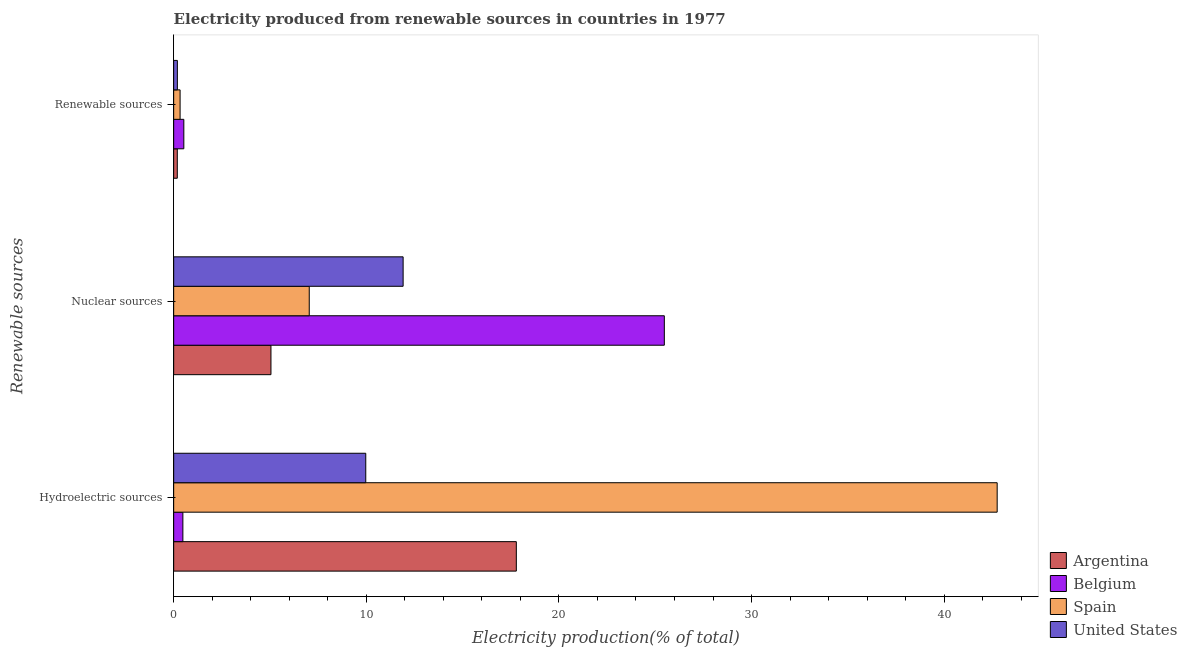Are the number of bars per tick equal to the number of legend labels?
Keep it short and to the point. Yes. Are the number of bars on each tick of the Y-axis equal?
Provide a succinct answer. Yes. How many bars are there on the 2nd tick from the top?
Make the answer very short. 4. How many bars are there on the 3rd tick from the bottom?
Your answer should be very brief. 4. What is the label of the 3rd group of bars from the top?
Offer a very short reply. Hydroelectric sources. What is the percentage of electricity produced by renewable sources in United States?
Provide a succinct answer. 0.19. Across all countries, what is the maximum percentage of electricity produced by renewable sources?
Your answer should be compact. 0.53. Across all countries, what is the minimum percentage of electricity produced by hydroelectric sources?
Keep it short and to the point. 0.48. In which country was the percentage of electricity produced by nuclear sources maximum?
Provide a succinct answer. Belgium. What is the total percentage of electricity produced by hydroelectric sources in the graph?
Provide a succinct answer. 70.99. What is the difference between the percentage of electricity produced by renewable sources in Argentina and that in Belgium?
Keep it short and to the point. -0.34. What is the difference between the percentage of electricity produced by hydroelectric sources in United States and the percentage of electricity produced by nuclear sources in Argentina?
Offer a terse response. 4.92. What is the average percentage of electricity produced by hydroelectric sources per country?
Make the answer very short. 17.75. What is the difference between the percentage of electricity produced by renewable sources and percentage of electricity produced by hydroelectric sources in Spain?
Keep it short and to the point. -42.42. What is the ratio of the percentage of electricity produced by hydroelectric sources in Spain to that in Argentina?
Make the answer very short. 2.4. Is the difference between the percentage of electricity produced by hydroelectric sources in United States and Argentina greater than the difference between the percentage of electricity produced by renewable sources in United States and Argentina?
Offer a terse response. No. What is the difference between the highest and the second highest percentage of electricity produced by hydroelectric sources?
Provide a short and direct response. 24.96. What is the difference between the highest and the lowest percentage of electricity produced by nuclear sources?
Provide a succinct answer. 20.42. In how many countries, is the percentage of electricity produced by nuclear sources greater than the average percentage of electricity produced by nuclear sources taken over all countries?
Your answer should be compact. 1. What does the 1st bar from the top in Nuclear sources represents?
Provide a succinct answer. United States. Are all the bars in the graph horizontal?
Ensure brevity in your answer.  Yes. How many countries are there in the graph?
Provide a succinct answer. 4. What is the difference between two consecutive major ticks on the X-axis?
Provide a succinct answer. 10. Does the graph contain any zero values?
Give a very brief answer. No. Does the graph contain grids?
Your answer should be compact. No. How many legend labels are there?
Provide a succinct answer. 4. What is the title of the graph?
Your answer should be compact. Electricity produced from renewable sources in countries in 1977. What is the label or title of the Y-axis?
Provide a short and direct response. Renewable sources. What is the Electricity production(% of total) of Argentina in Hydroelectric sources?
Your answer should be very brief. 17.79. What is the Electricity production(% of total) of Belgium in Hydroelectric sources?
Offer a terse response. 0.48. What is the Electricity production(% of total) in Spain in Hydroelectric sources?
Your answer should be very brief. 42.75. What is the Electricity production(% of total) in United States in Hydroelectric sources?
Keep it short and to the point. 9.97. What is the Electricity production(% of total) of Argentina in Nuclear sources?
Provide a short and direct response. 5.05. What is the Electricity production(% of total) of Belgium in Nuclear sources?
Offer a terse response. 25.47. What is the Electricity production(% of total) in Spain in Nuclear sources?
Ensure brevity in your answer.  7.04. What is the Electricity production(% of total) of United States in Nuclear sources?
Your answer should be compact. 11.91. What is the Electricity production(% of total) in Argentina in Renewable sources?
Keep it short and to the point. 0.19. What is the Electricity production(% of total) of Belgium in Renewable sources?
Offer a terse response. 0.53. What is the Electricity production(% of total) of Spain in Renewable sources?
Offer a terse response. 0.33. What is the Electricity production(% of total) in United States in Renewable sources?
Ensure brevity in your answer.  0.19. Across all Renewable sources, what is the maximum Electricity production(% of total) in Argentina?
Keep it short and to the point. 17.79. Across all Renewable sources, what is the maximum Electricity production(% of total) of Belgium?
Your answer should be very brief. 25.47. Across all Renewable sources, what is the maximum Electricity production(% of total) of Spain?
Your response must be concise. 42.75. Across all Renewable sources, what is the maximum Electricity production(% of total) in United States?
Give a very brief answer. 11.91. Across all Renewable sources, what is the minimum Electricity production(% of total) in Argentina?
Your answer should be compact. 0.19. Across all Renewable sources, what is the minimum Electricity production(% of total) of Belgium?
Provide a short and direct response. 0.48. Across all Renewable sources, what is the minimum Electricity production(% of total) in Spain?
Offer a very short reply. 0.33. Across all Renewable sources, what is the minimum Electricity production(% of total) of United States?
Ensure brevity in your answer.  0.19. What is the total Electricity production(% of total) in Argentina in the graph?
Your answer should be compact. 23.03. What is the total Electricity production(% of total) of Belgium in the graph?
Give a very brief answer. 26.48. What is the total Electricity production(% of total) in Spain in the graph?
Offer a terse response. 50.13. What is the total Electricity production(% of total) of United States in the graph?
Your response must be concise. 22.08. What is the difference between the Electricity production(% of total) of Argentina in Hydroelectric sources and that in Nuclear sources?
Provide a succinct answer. 12.74. What is the difference between the Electricity production(% of total) in Belgium in Hydroelectric sources and that in Nuclear sources?
Your answer should be compact. -25. What is the difference between the Electricity production(% of total) in Spain in Hydroelectric sources and that in Nuclear sources?
Make the answer very short. 35.72. What is the difference between the Electricity production(% of total) of United States in Hydroelectric sources and that in Nuclear sources?
Ensure brevity in your answer.  -1.94. What is the difference between the Electricity production(% of total) in Argentina in Hydroelectric sources and that in Renewable sources?
Your answer should be very brief. 17.6. What is the difference between the Electricity production(% of total) in Belgium in Hydroelectric sources and that in Renewable sources?
Provide a short and direct response. -0.05. What is the difference between the Electricity production(% of total) of Spain in Hydroelectric sources and that in Renewable sources?
Your answer should be compact. 42.42. What is the difference between the Electricity production(% of total) of United States in Hydroelectric sources and that in Renewable sources?
Your answer should be compact. 9.78. What is the difference between the Electricity production(% of total) of Argentina in Nuclear sources and that in Renewable sources?
Ensure brevity in your answer.  4.86. What is the difference between the Electricity production(% of total) of Belgium in Nuclear sources and that in Renewable sources?
Provide a short and direct response. 24.95. What is the difference between the Electricity production(% of total) of Spain in Nuclear sources and that in Renewable sources?
Give a very brief answer. 6.71. What is the difference between the Electricity production(% of total) in United States in Nuclear sources and that in Renewable sources?
Your response must be concise. 11.72. What is the difference between the Electricity production(% of total) in Argentina in Hydroelectric sources and the Electricity production(% of total) in Belgium in Nuclear sources?
Your response must be concise. -7.68. What is the difference between the Electricity production(% of total) in Argentina in Hydroelectric sources and the Electricity production(% of total) in Spain in Nuclear sources?
Give a very brief answer. 10.75. What is the difference between the Electricity production(% of total) of Argentina in Hydroelectric sources and the Electricity production(% of total) of United States in Nuclear sources?
Keep it short and to the point. 5.88. What is the difference between the Electricity production(% of total) in Belgium in Hydroelectric sources and the Electricity production(% of total) in Spain in Nuclear sources?
Give a very brief answer. -6.56. What is the difference between the Electricity production(% of total) in Belgium in Hydroelectric sources and the Electricity production(% of total) in United States in Nuclear sources?
Ensure brevity in your answer.  -11.43. What is the difference between the Electricity production(% of total) in Spain in Hydroelectric sources and the Electricity production(% of total) in United States in Nuclear sources?
Your answer should be very brief. 30.84. What is the difference between the Electricity production(% of total) in Argentina in Hydroelectric sources and the Electricity production(% of total) in Belgium in Renewable sources?
Your answer should be very brief. 17.26. What is the difference between the Electricity production(% of total) of Argentina in Hydroelectric sources and the Electricity production(% of total) of Spain in Renewable sources?
Your answer should be compact. 17.46. What is the difference between the Electricity production(% of total) of Argentina in Hydroelectric sources and the Electricity production(% of total) of United States in Renewable sources?
Offer a very short reply. 17.6. What is the difference between the Electricity production(% of total) of Belgium in Hydroelectric sources and the Electricity production(% of total) of Spain in Renewable sources?
Provide a succinct answer. 0.14. What is the difference between the Electricity production(% of total) in Belgium in Hydroelectric sources and the Electricity production(% of total) in United States in Renewable sources?
Give a very brief answer. 0.29. What is the difference between the Electricity production(% of total) in Spain in Hydroelectric sources and the Electricity production(% of total) in United States in Renewable sources?
Offer a terse response. 42.56. What is the difference between the Electricity production(% of total) in Argentina in Nuclear sources and the Electricity production(% of total) in Belgium in Renewable sources?
Give a very brief answer. 4.52. What is the difference between the Electricity production(% of total) of Argentina in Nuclear sources and the Electricity production(% of total) of Spain in Renewable sources?
Provide a succinct answer. 4.72. What is the difference between the Electricity production(% of total) in Argentina in Nuclear sources and the Electricity production(% of total) in United States in Renewable sources?
Offer a very short reply. 4.86. What is the difference between the Electricity production(% of total) of Belgium in Nuclear sources and the Electricity production(% of total) of Spain in Renewable sources?
Give a very brief answer. 25.14. What is the difference between the Electricity production(% of total) of Belgium in Nuclear sources and the Electricity production(% of total) of United States in Renewable sources?
Give a very brief answer. 25.28. What is the difference between the Electricity production(% of total) of Spain in Nuclear sources and the Electricity production(% of total) of United States in Renewable sources?
Provide a succinct answer. 6.85. What is the average Electricity production(% of total) in Argentina per Renewable sources?
Make the answer very short. 7.68. What is the average Electricity production(% of total) of Belgium per Renewable sources?
Provide a succinct answer. 8.83. What is the average Electricity production(% of total) in Spain per Renewable sources?
Keep it short and to the point. 16.71. What is the average Electricity production(% of total) of United States per Renewable sources?
Keep it short and to the point. 7.36. What is the difference between the Electricity production(% of total) in Argentina and Electricity production(% of total) in Belgium in Hydroelectric sources?
Your answer should be compact. 17.31. What is the difference between the Electricity production(% of total) of Argentina and Electricity production(% of total) of Spain in Hydroelectric sources?
Make the answer very short. -24.96. What is the difference between the Electricity production(% of total) of Argentina and Electricity production(% of total) of United States in Hydroelectric sources?
Make the answer very short. 7.82. What is the difference between the Electricity production(% of total) of Belgium and Electricity production(% of total) of Spain in Hydroelectric sources?
Keep it short and to the point. -42.28. What is the difference between the Electricity production(% of total) of Belgium and Electricity production(% of total) of United States in Hydroelectric sources?
Offer a very short reply. -9.49. What is the difference between the Electricity production(% of total) of Spain and Electricity production(% of total) of United States in Hydroelectric sources?
Make the answer very short. 32.78. What is the difference between the Electricity production(% of total) in Argentina and Electricity production(% of total) in Belgium in Nuclear sources?
Your response must be concise. -20.42. What is the difference between the Electricity production(% of total) of Argentina and Electricity production(% of total) of Spain in Nuclear sources?
Keep it short and to the point. -1.99. What is the difference between the Electricity production(% of total) in Argentina and Electricity production(% of total) in United States in Nuclear sources?
Make the answer very short. -6.86. What is the difference between the Electricity production(% of total) in Belgium and Electricity production(% of total) in Spain in Nuclear sources?
Make the answer very short. 18.43. What is the difference between the Electricity production(% of total) in Belgium and Electricity production(% of total) in United States in Nuclear sources?
Provide a short and direct response. 13.56. What is the difference between the Electricity production(% of total) in Spain and Electricity production(% of total) in United States in Nuclear sources?
Make the answer very short. -4.87. What is the difference between the Electricity production(% of total) in Argentina and Electricity production(% of total) in Belgium in Renewable sources?
Offer a very short reply. -0.34. What is the difference between the Electricity production(% of total) of Argentina and Electricity production(% of total) of Spain in Renewable sources?
Your response must be concise. -0.15. What is the difference between the Electricity production(% of total) in Argentina and Electricity production(% of total) in United States in Renewable sources?
Offer a very short reply. -0. What is the difference between the Electricity production(% of total) in Belgium and Electricity production(% of total) in Spain in Renewable sources?
Offer a terse response. 0.19. What is the difference between the Electricity production(% of total) in Belgium and Electricity production(% of total) in United States in Renewable sources?
Provide a succinct answer. 0.34. What is the difference between the Electricity production(% of total) of Spain and Electricity production(% of total) of United States in Renewable sources?
Your answer should be very brief. 0.14. What is the ratio of the Electricity production(% of total) in Argentina in Hydroelectric sources to that in Nuclear sources?
Make the answer very short. 3.52. What is the ratio of the Electricity production(% of total) in Belgium in Hydroelectric sources to that in Nuclear sources?
Make the answer very short. 0.02. What is the ratio of the Electricity production(% of total) in Spain in Hydroelectric sources to that in Nuclear sources?
Give a very brief answer. 6.07. What is the ratio of the Electricity production(% of total) of United States in Hydroelectric sources to that in Nuclear sources?
Keep it short and to the point. 0.84. What is the ratio of the Electricity production(% of total) in Argentina in Hydroelectric sources to that in Renewable sources?
Provide a short and direct response. 94.52. What is the ratio of the Electricity production(% of total) of Belgium in Hydroelectric sources to that in Renewable sources?
Provide a short and direct response. 0.91. What is the ratio of the Electricity production(% of total) in Spain in Hydroelectric sources to that in Renewable sources?
Make the answer very short. 128.25. What is the ratio of the Electricity production(% of total) of United States in Hydroelectric sources to that in Renewable sources?
Give a very brief answer. 51.95. What is the ratio of the Electricity production(% of total) of Argentina in Nuclear sources to that in Renewable sources?
Provide a short and direct response. 26.84. What is the ratio of the Electricity production(% of total) of Belgium in Nuclear sources to that in Renewable sources?
Ensure brevity in your answer.  48.34. What is the ratio of the Electricity production(% of total) of Spain in Nuclear sources to that in Renewable sources?
Your response must be concise. 21.11. What is the ratio of the Electricity production(% of total) in United States in Nuclear sources to that in Renewable sources?
Your response must be concise. 62.05. What is the difference between the highest and the second highest Electricity production(% of total) in Argentina?
Provide a short and direct response. 12.74. What is the difference between the highest and the second highest Electricity production(% of total) in Belgium?
Provide a succinct answer. 24.95. What is the difference between the highest and the second highest Electricity production(% of total) in Spain?
Your answer should be compact. 35.72. What is the difference between the highest and the second highest Electricity production(% of total) in United States?
Your answer should be compact. 1.94. What is the difference between the highest and the lowest Electricity production(% of total) of Argentina?
Ensure brevity in your answer.  17.6. What is the difference between the highest and the lowest Electricity production(% of total) of Belgium?
Give a very brief answer. 25. What is the difference between the highest and the lowest Electricity production(% of total) in Spain?
Your answer should be very brief. 42.42. What is the difference between the highest and the lowest Electricity production(% of total) of United States?
Provide a short and direct response. 11.72. 